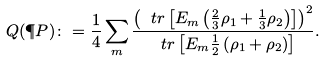<formula> <loc_0><loc_0><loc_500><loc_500>Q ( \P P ) \colon = \frac { 1 } { 4 } \sum _ { m } \frac { \left ( \ t r \left [ E _ { m } \left ( \frac { 2 } { 3 } \rho _ { 1 } + \frac { 1 } { 3 } \rho _ { 2 } \right ) \right ] \right ) ^ { 2 } } { \ t r \left [ E _ { m } \frac { 1 } { 2 } \left ( \rho _ { 1 } + \rho _ { 2 } \right ) \right ] } .</formula> 